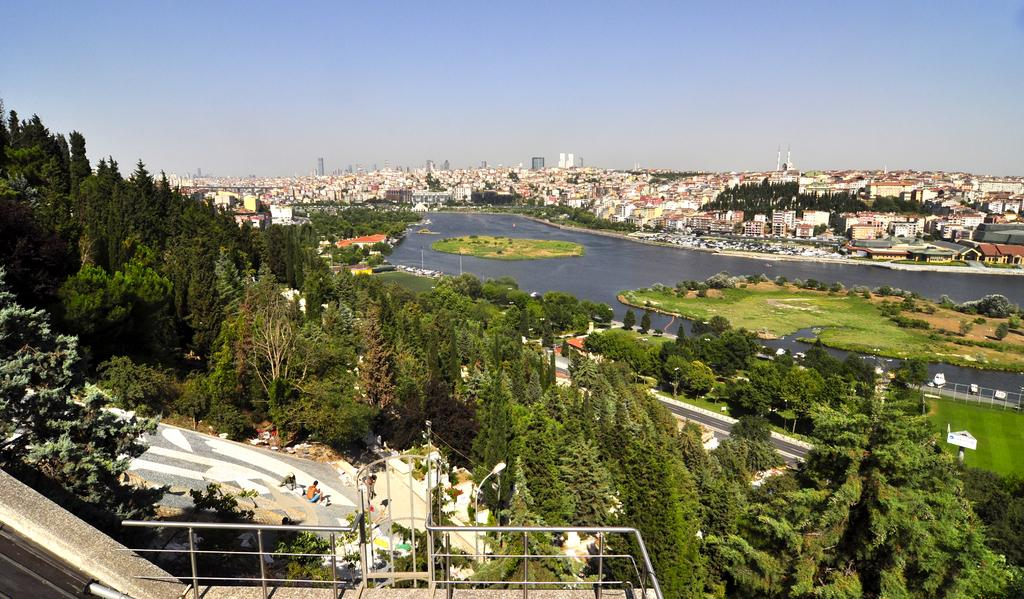What is the main feature in the center of the image? There is water in the center of the image. What type of vegetation can be seen in the image? There are trees, plants, and grass in the image. What structures are present in the image? There are fences, poles, and sign boards in the image. What are the people in the image doing? There are people sitting in the image. What can be seen in the background of the image? There is sky, buildings, and additional trees visible in the background of the image. How many cakes are being served to the people sitting in the image? There is no mention of cakes in the image; it features water, vegetation, structures, people, and the background. 